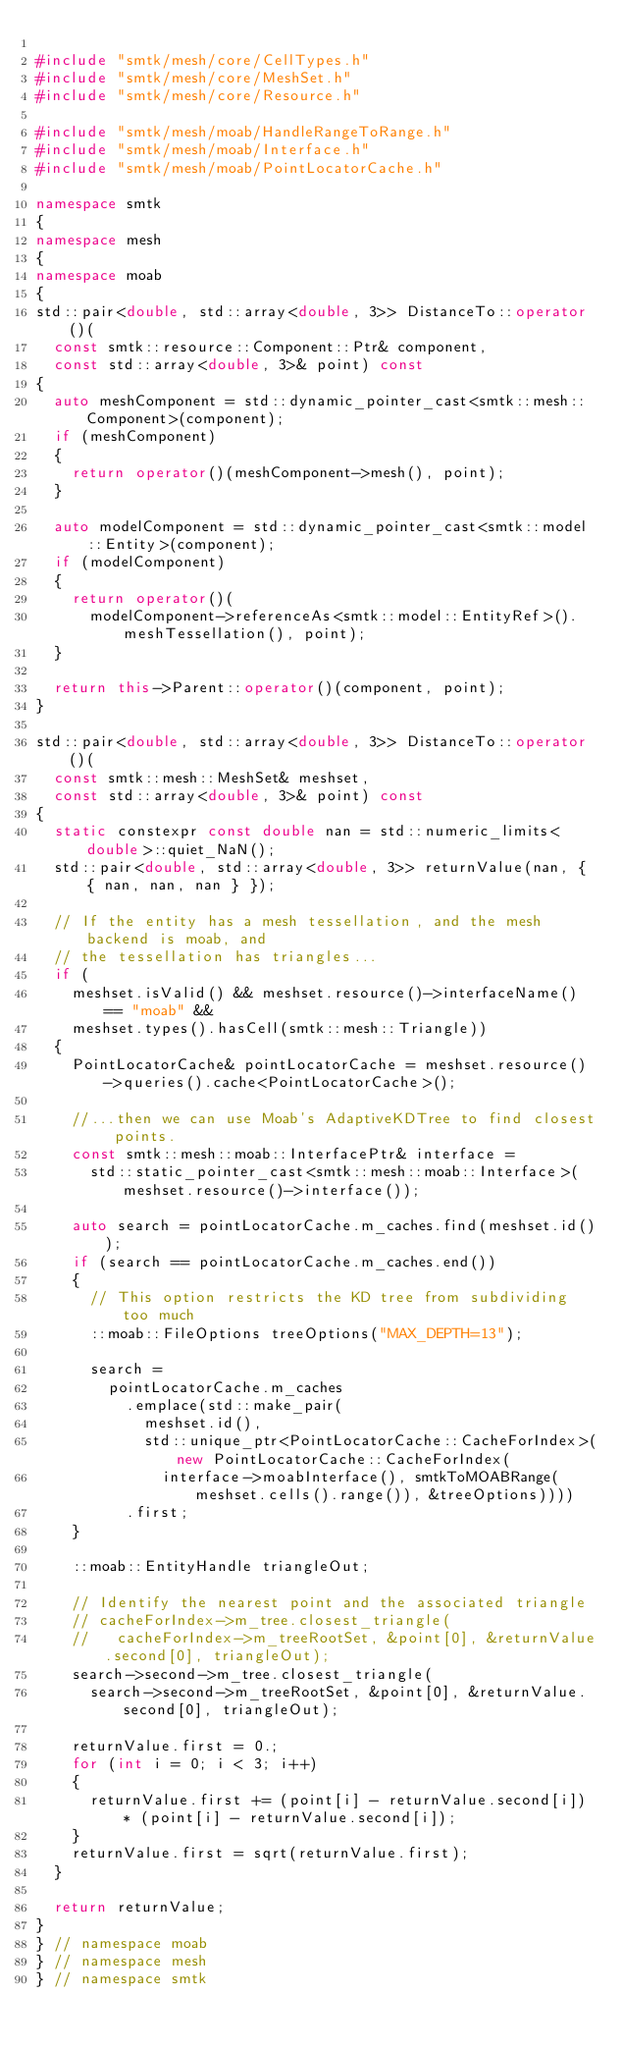Convert code to text. <code><loc_0><loc_0><loc_500><loc_500><_C++_>
#include "smtk/mesh/core/CellTypes.h"
#include "smtk/mesh/core/MeshSet.h"
#include "smtk/mesh/core/Resource.h"

#include "smtk/mesh/moab/HandleRangeToRange.h"
#include "smtk/mesh/moab/Interface.h"
#include "smtk/mesh/moab/PointLocatorCache.h"

namespace smtk
{
namespace mesh
{
namespace moab
{
std::pair<double, std::array<double, 3>> DistanceTo::operator()(
  const smtk::resource::Component::Ptr& component,
  const std::array<double, 3>& point) const
{
  auto meshComponent = std::dynamic_pointer_cast<smtk::mesh::Component>(component);
  if (meshComponent)
  {
    return operator()(meshComponent->mesh(), point);
  }

  auto modelComponent = std::dynamic_pointer_cast<smtk::model::Entity>(component);
  if (modelComponent)
  {
    return operator()(
      modelComponent->referenceAs<smtk::model::EntityRef>().meshTessellation(), point);
  }

  return this->Parent::operator()(component, point);
}

std::pair<double, std::array<double, 3>> DistanceTo::operator()(
  const smtk::mesh::MeshSet& meshset,
  const std::array<double, 3>& point) const
{
  static constexpr const double nan = std::numeric_limits<double>::quiet_NaN();
  std::pair<double, std::array<double, 3>> returnValue(nan, { { nan, nan, nan } });

  // If the entity has a mesh tessellation, and the mesh backend is moab, and
  // the tessellation has triangles...
  if (
    meshset.isValid() && meshset.resource()->interfaceName() == "moab" &&
    meshset.types().hasCell(smtk::mesh::Triangle))
  {
    PointLocatorCache& pointLocatorCache = meshset.resource()->queries().cache<PointLocatorCache>();

    //...then we can use Moab's AdaptiveKDTree to find closest points.
    const smtk::mesh::moab::InterfacePtr& interface =
      std::static_pointer_cast<smtk::mesh::moab::Interface>(meshset.resource()->interface());

    auto search = pointLocatorCache.m_caches.find(meshset.id());
    if (search == pointLocatorCache.m_caches.end())
    {
      // This option restricts the KD tree from subdividing too much
      ::moab::FileOptions treeOptions("MAX_DEPTH=13");

      search =
        pointLocatorCache.m_caches
          .emplace(std::make_pair(
            meshset.id(),
            std::unique_ptr<PointLocatorCache::CacheForIndex>(new PointLocatorCache::CacheForIndex(
              interface->moabInterface(), smtkToMOABRange(meshset.cells().range()), &treeOptions))))
          .first;
    }

    ::moab::EntityHandle triangleOut;

    // Identify the nearest point and the associated triangle
    // cacheForIndex->m_tree.closest_triangle(
    //   cacheForIndex->m_treeRootSet, &point[0], &returnValue.second[0], triangleOut);
    search->second->m_tree.closest_triangle(
      search->second->m_treeRootSet, &point[0], &returnValue.second[0], triangleOut);

    returnValue.first = 0.;
    for (int i = 0; i < 3; i++)
    {
      returnValue.first += (point[i] - returnValue.second[i]) * (point[i] - returnValue.second[i]);
    }
    returnValue.first = sqrt(returnValue.first);
  }

  return returnValue;
}
} // namespace moab
} // namespace mesh
} // namespace smtk
</code> 